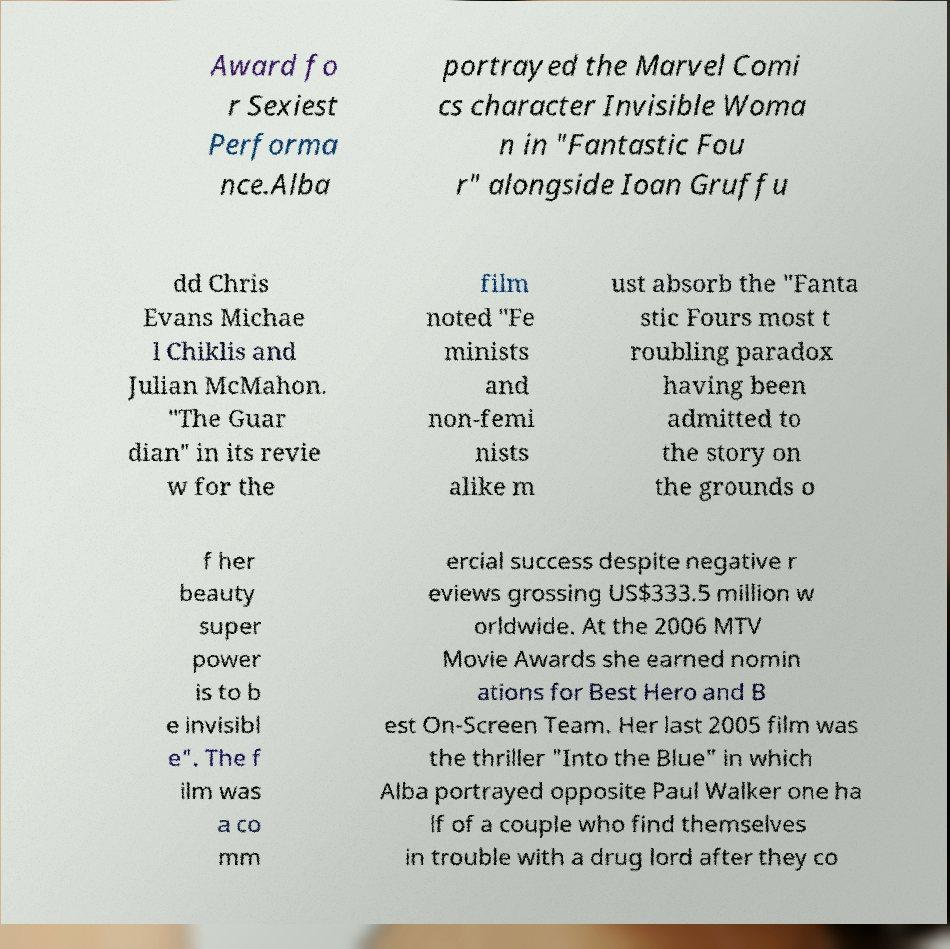Could you assist in decoding the text presented in this image and type it out clearly? Award fo r Sexiest Performa nce.Alba portrayed the Marvel Comi cs character Invisible Woma n in "Fantastic Fou r" alongside Ioan Gruffu dd Chris Evans Michae l Chiklis and Julian McMahon. "The Guar dian" in its revie w for the film noted "Fe minists and non-femi nists alike m ust absorb the "Fanta stic Fours most t roubling paradox having been admitted to the story on the grounds o f her beauty super power is to b e invisibl e". The f ilm was a co mm ercial success despite negative r eviews grossing US$333.5 million w orldwide. At the 2006 MTV Movie Awards she earned nomin ations for Best Hero and B est On-Screen Team. Her last 2005 film was the thriller "Into the Blue" in which Alba portrayed opposite Paul Walker one ha lf of a couple who find themselves in trouble with a drug lord after they co 